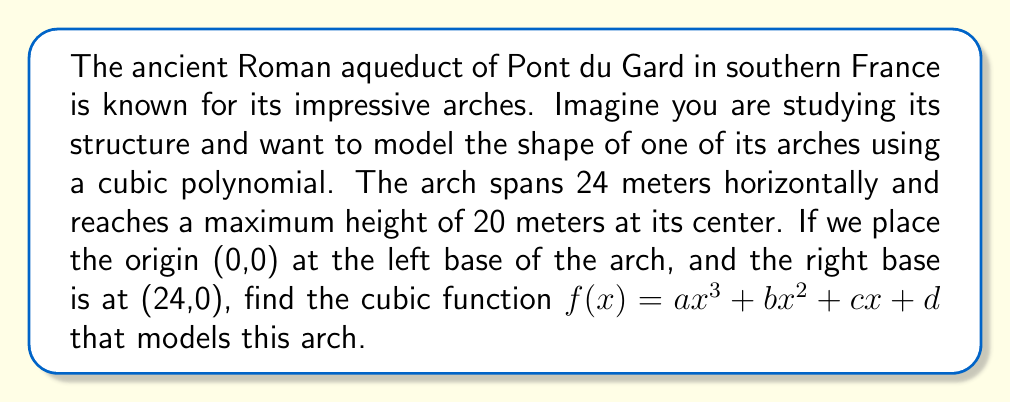Can you answer this question? Let's approach this step-by-step:

1) We know that the cubic function must pass through the following points:
   (0,0), (24,0), and (12,20)

2) We also know that the function should be symmetric about x = 12, which means there should be no $x$ term. So, $c = 0$.

3) Our function now looks like: $f(x) = ax^3 + bx^2 + d$

4) Using the points (0,0) and (24,0):
   $f(0) = d = 0$
   $f(24) = a(24^3) + b(24^2) = 0$

5) Using the point (12,20):
   $f(12) = a(12^3) + b(12^2) = 20$

6) From step 4:
   $a(13824) + b(576) = 0$
   $24a + b = 0$  ... (Equation 1)

7) From step 5:
   $1728a + 144b = 20$  ... (Equation 2)

8) Multiply Equation 1 by 72:
   $1728a + 72b = 0$  ... (Equation 3)

9) Subtract Equation 3 from Equation 2:
   $72b = 20$
   $b = \frac{5}{18}$

10) Substitute this value of $b$ in Equation 1:
    $24a + \frac{5}{18} = 0$
    $a = -\frac{5}{432}$

Therefore, the cubic function is:

$f(x) = -\frac{5}{432}x^3 + \frac{5}{18}x^2$
Answer: $f(x) = -\frac{5}{432}x^3 + \frac{5}{18}x^2$ 